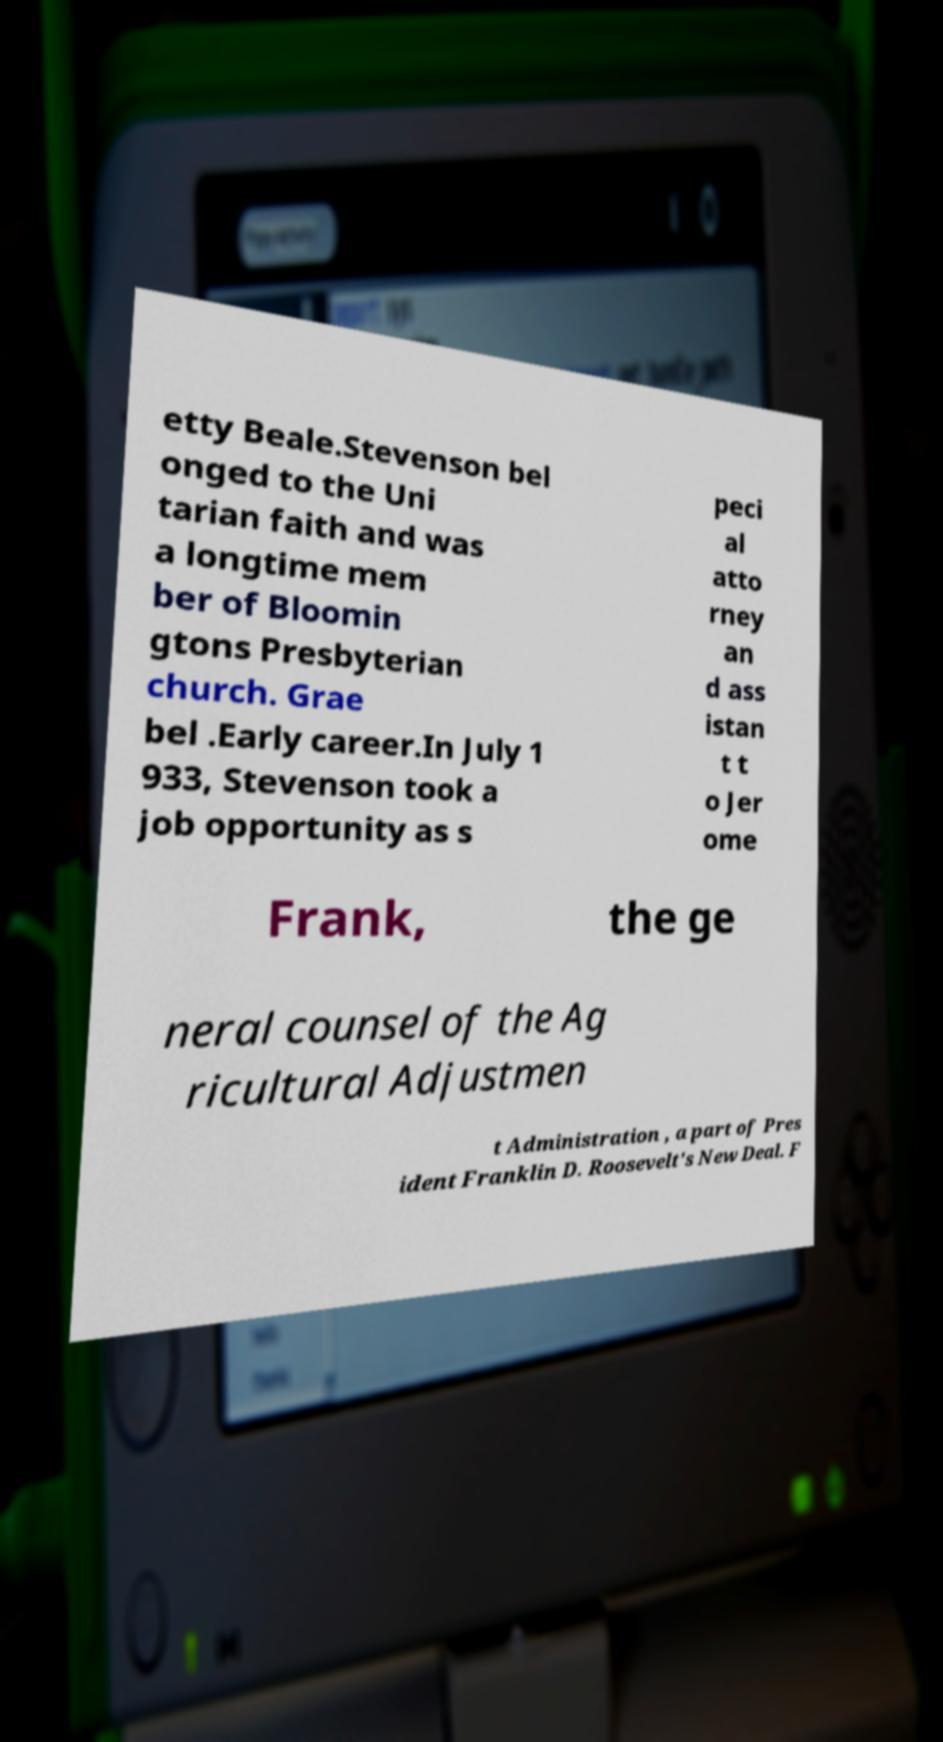I need the written content from this picture converted into text. Can you do that? etty Beale.Stevenson bel onged to the Uni tarian faith and was a longtime mem ber of Bloomin gtons Presbyterian church. Grae bel .Early career.In July 1 933, Stevenson took a job opportunity as s peci al atto rney an d ass istan t t o Jer ome Frank, the ge neral counsel of the Ag ricultural Adjustmen t Administration , a part of Pres ident Franklin D. Roosevelt's New Deal. F 